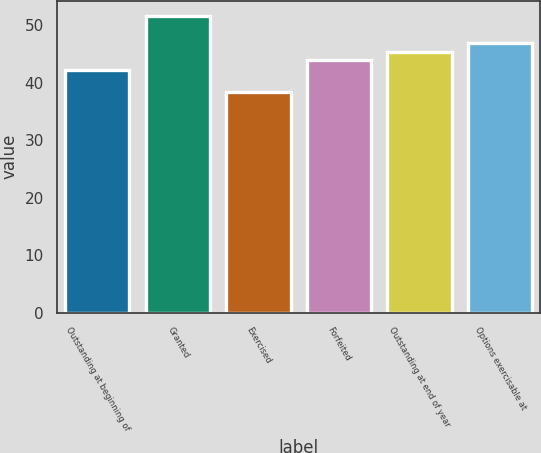Convert chart. <chart><loc_0><loc_0><loc_500><loc_500><bar_chart><fcel>Outstanding at beginning of<fcel>Granted<fcel>Exercised<fcel>Forfeited<fcel>Outstanding at end of year<fcel>Options exercisable at<nl><fcel>42.21<fcel>51.62<fcel>38.3<fcel>43.9<fcel>45.23<fcel>46.95<nl></chart> 